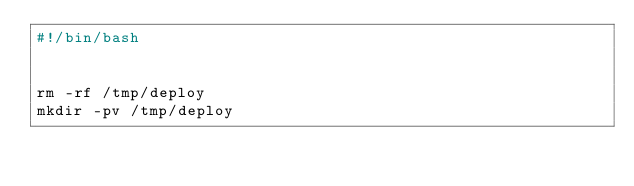<code> <loc_0><loc_0><loc_500><loc_500><_Bash_>#!/bin/bash


rm -rf /tmp/deploy
mkdir -pv /tmp/deploy
</code> 